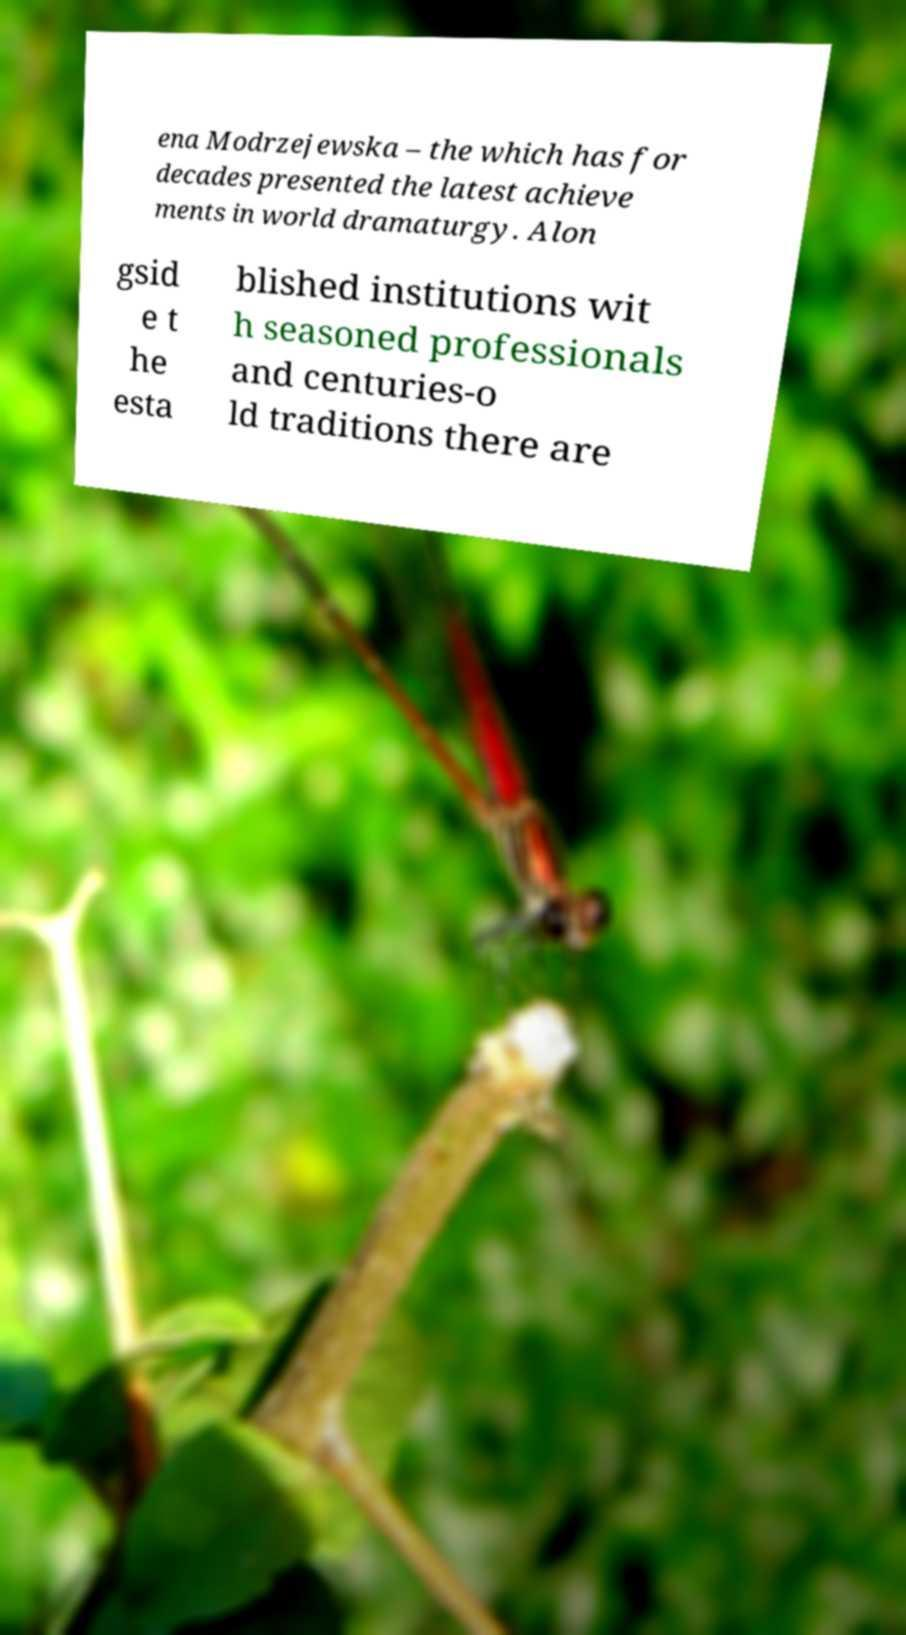Please identify and transcribe the text found in this image. ena Modrzejewska – the which has for decades presented the latest achieve ments in world dramaturgy. Alon gsid e t he esta blished institutions wit h seasoned professionals and centuries-o ld traditions there are 